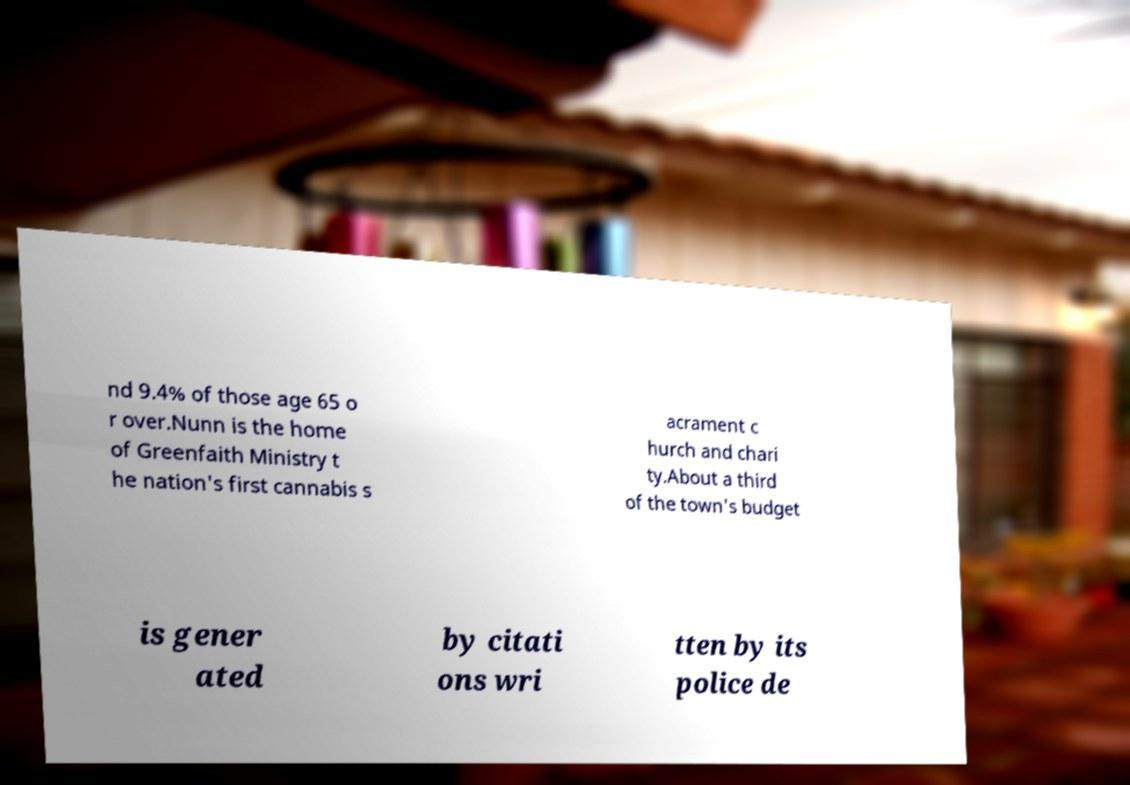Could you assist in decoding the text presented in this image and type it out clearly? nd 9.4% of those age 65 o r over.Nunn is the home of Greenfaith Ministry t he nation's first cannabis s acrament c hurch and chari ty.About a third of the town's budget is gener ated by citati ons wri tten by its police de 